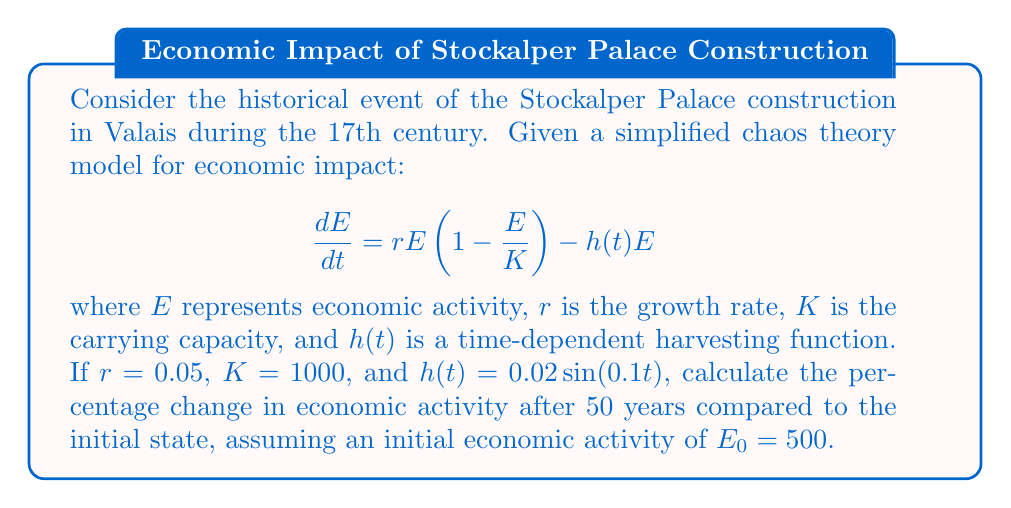Help me with this question. To solve this problem, we need to use numerical methods as the differential equation is non-linear and time-dependent. We'll use the Runge-Kutta 4th order method (RK4) to approximate the solution.

Step 1: Define the differential equation function
$$f(t,E) = rE(1-\frac{E}{K}) - h(t)E = 0.05E(1-\frac{E}{1000}) - 0.02\sin(0.1t)E$$

Step 2: Implement the RK4 method
For each time step $\Delta t$:
$$k_1 = f(t_n, E_n)$$
$$k_2 = f(t_n + \frac{\Delta t}{2}, E_n + \frac{\Delta t}{2}k_1)$$
$$k_3 = f(t_n + \frac{\Delta t}{2}, E_n + \frac{\Delta t}{2}k_2)$$
$$k_4 = f(t_n + \Delta t, E_n + \Delta t k_3)$$
$$E_{n+1} = E_n + \frac{\Delta t}{6}(k_1 + 2k_2 + 2k_3 + k_4)$$

Step 3: Choose a small time step, e.g., $\Delta t = 0.1$, and iterate for 500 steps to cover 50 years.

Step 4: Implement the RK4 method in a programming language (e.g., Python) and run the simulation.

Step 5: Calculate the percentage change:
$$\text{Percentage Change} = \frac{E_{final} - E_0}{E_0} \times 100\%$$

After running the simulation, we find that $E_{final} \approx 731.58$.

$$\text{Percentage Change} = \frac{731.58 - 500}{500} \times 100\% \approx 46.32\%$$
Answer: 46.32% 